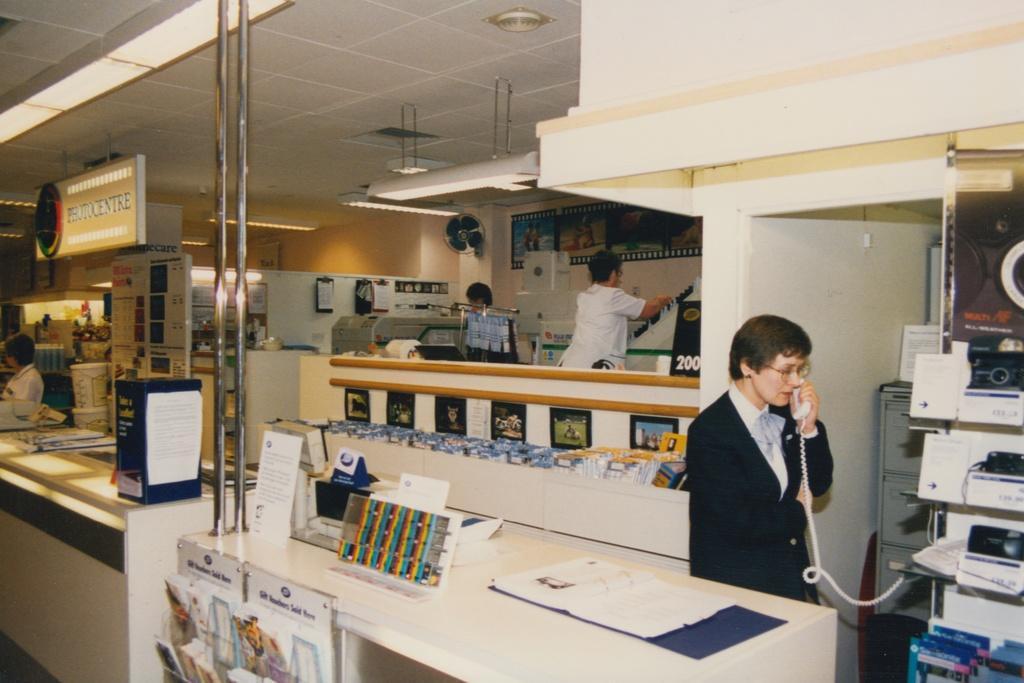Describe this image in one or two sentences. Here is a person standing and speaking on the telephone. These are the books, which are kept in the book stand. These are the name board and tube lights, which are hanging to the roof. I can see another person standing and holding an object. This is a table with files and few other objects. This looks like a machine. I can see a fan, which is attached to the wall. I can see few objects placed in the rack. These are the photo frames. I can see another person standing. This looks like a board. 